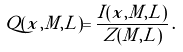Convert formula to latex. <formula><loc_0><loc_0><loc_500><loc_500>Q ( x , M , L ) = \frac { I ( x , M , L ) } { Z ( M , L ) } \, .</formula> 